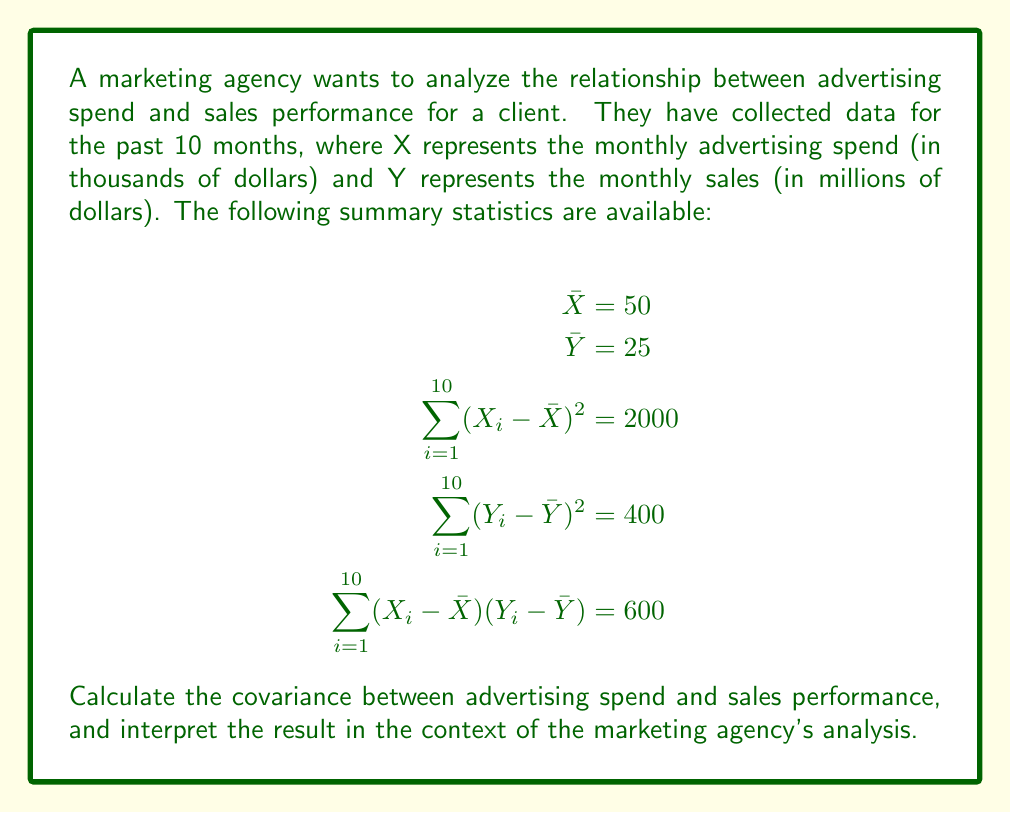Give your solution to this math problem. To solve this problem, we'll follow these steps:

1. Recall the formula for covariance:
   $$Cov(X,Y) = \frac{1}{n} \sum_{i=1}^{n} (X_i - \bar{X})(Y_i - \bar{Y})$$

2. We're given $\sum_{i=1}^{10} (X_i - \bar{X})(Y_i - \bar{Y}) = 600$ and $n = 10$ (10 months of data).

3. Plug these values into the covariance formula:
   $$Cov(X,Y) = \frac{1}{10} \cdot 600 = 60$$

4. Interpret the result:
   - The covariance is positive, indicating a positive linear relationship between advertising spend and sales performance.
   - The magnitude of the covariance (60) suggests a relatively strong relationship, but it's difficult to interpret on its own due to the scale dependence of covariance.

5. To provide more context, we can calculate the correlation coefficient:
   $$r = \frac{Cov(X,Y)}{\sqrt{Var(X) \cdot Var(Y)}}$$

   Where $Var(X) = \frac{1}{n} \sum_{i=1}^{n} (X_i - \bar{X})^2$ and $Var(Y) = \frac{1}{n} \sum_{i=1}^{n} (Y_i - \bar{Y})^2$

6. Calculate $Var(X)$ and $Var(Y)$:
   $$Var(X) = \frac{1}{10} \cdot 2000 = 200$$
   $$Var(Y) = \frac{1}{10} \cdot 400 = 40$$

7. Calculate the correlation coefficient:
   $$r = \frac{60}{\sqrt{200 \cdot 40}} = \frac{60}{\sqrt{8000}} = \frac{60}{89.44} \approx 0.67$$

8. Interpret the correlation coefficient:
   - The correlation coefficient of 0.67 indicates a moderately strong positive linear relationship between advertising spend and sales performance.
   - This suggests that as advertising spend increases, sales performance tends to increase as well.
Answer: Covariance = 60; Positive relationship between advertising spend and sales performance 